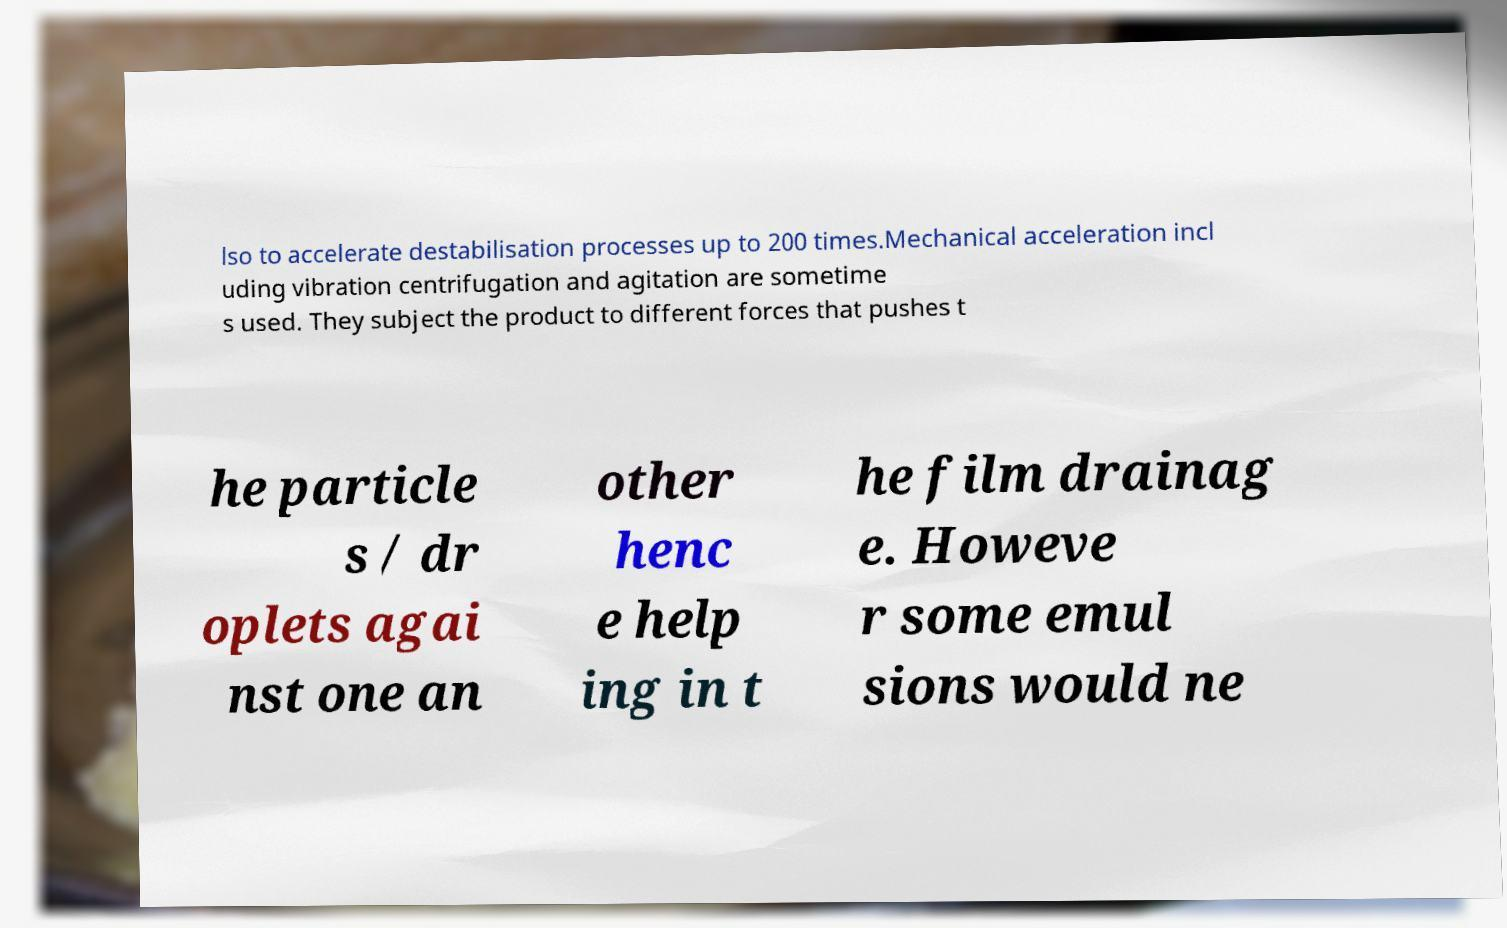I need the written content from this picture converted into text. Can you do that? lso to accelerate destabilisation processes up to 200 times.Mechanical acceleration incl uding vibration centrifugation and agitation are sometime s used. They subject the product to different forces that pushes t he particle s / dr oplets agai nst one an other henc e help ing in t he film drainag e. Howeve r some emul sions would ne 